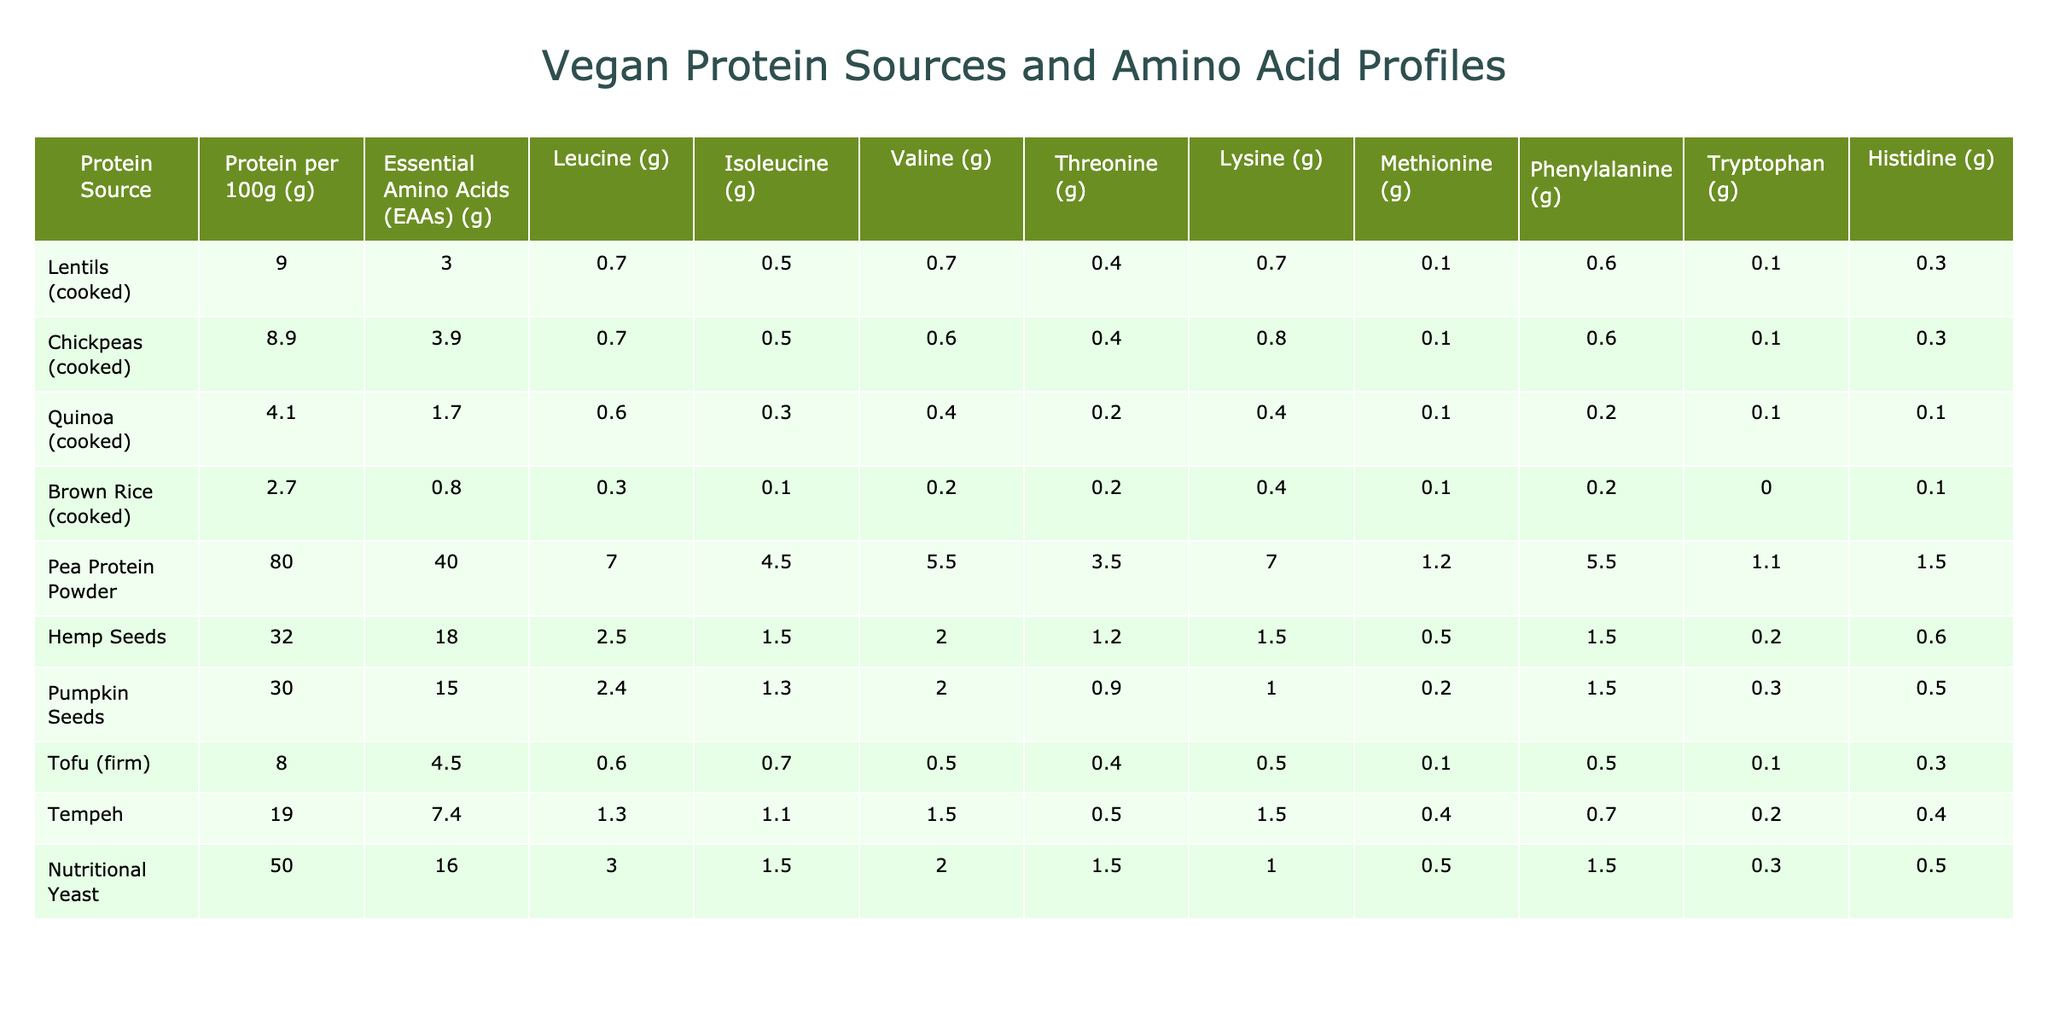What is the protein content of lentils per 100g? The table shows that lentils have a protein content of 9.0g per 100g.
Answer: 9.0g Which protein source has the highest protein content? In the table, pea protein powder has the highest protein content at 80.0g per 100g.
Answer: Pea Protein Powder What is the leucine content in chickpeas per 100g? The table indicates that chickpeas contain 0.7g of leucine per 100g.
Answer: 0.7g How much total essential amino acids (EAAs) do hemp seeds provide per 100g? According to the table, hemp seeds provide 18.0g of essential amino acids per 100g.
Answer: 18.0g Is the protein content of brown rice higher than quinoa? Yes, brown rice has a protein content of 2.7g while quinoa has 4.1g, which is not higher.
Answer: No What is the average protein content of tofu and tempeh combined? The protein content for tofu is 8.0g and for tempeh is 19.0g. The average is (8.0 + 19.0) / 2 = 13.5g.
Answer: 13.5g Which protein source has the highest lysine content, and what is that amount? From the table, pea protein powder has the highest lysine content at 7.0g per 100g.
Answer: Pea Protein Powder, 7.0g How many grams of valine does pumpkin seeds provide compared to lentils? Pumpkin seeds provide 2.0g of valine while lentils provide 0.7g. The difference is 2.0g - 0.7g = 1.3g more from pumpkin seeds.
Answer: 1.3g What is the total leucine content from lentils, chickpeas, and tofu combined? The leucine content is 0.7g in lentils, 0.7g in chickpeas, and 0.6g in tofu. The total is 0.7 + 0.7 + 0.6 = 2.0g.
Answer: 2.0g Is the methionine content in nutritional yeast equal or greater than that in tempeh? Nutritional yeast has 0.5g of methionine while tempeh has 0.4g, so nutritional yeast contains more.
Answer: Yes 